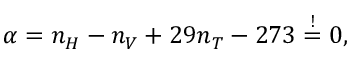Convert formula to latex. <formula><loc_0><loc_0><loc_500><loc_500>\alpha = n _ { H } - n _ { V } + 2 9 n _ { T } - 2 7 3 \stackrel { ! } { = } 0 ,</formula> 